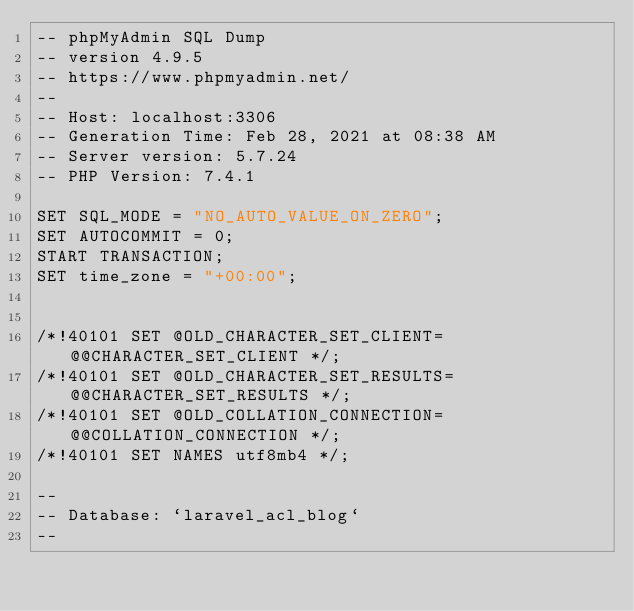Convert code to text. <code><loc_0><loc_0><loc_500><loc_500><_SQL_>-- phpMyAdmin SQL Dump
-- version 4.9.5
-- https://www.phpmyadmin.net/
--
-- Host: localhost:3306
-- Generation Time: Feb 28, 2021 at 08:38 AM
-- Server version: 5.7.24
-- PHP Version: 7.4.1

SET SQL_MODE = "NO_AUTO_VALUE_ON_ZERO";
SET AUTOCOMMIT = 0;
START TRANSACTION;
SET time_zone = "+00:00";


/*!40101 SET @OLD_CHARACTER_SET_CLIENT=@@CHARACTER_SET_CLIENT */;
/*!40101 SET @OLD_CHARACTER_SET_RESULTS=@@CHARACTER_SET_RESULTS */;
/*!40101 SET @OLD_COLLATION_CONNECTION=@@COLLATION_CONNECTION */;
/*!40101 SET NAMES utf8mb4 */;

--
-- Database: `laravel_acl_blog`
--
</code> 